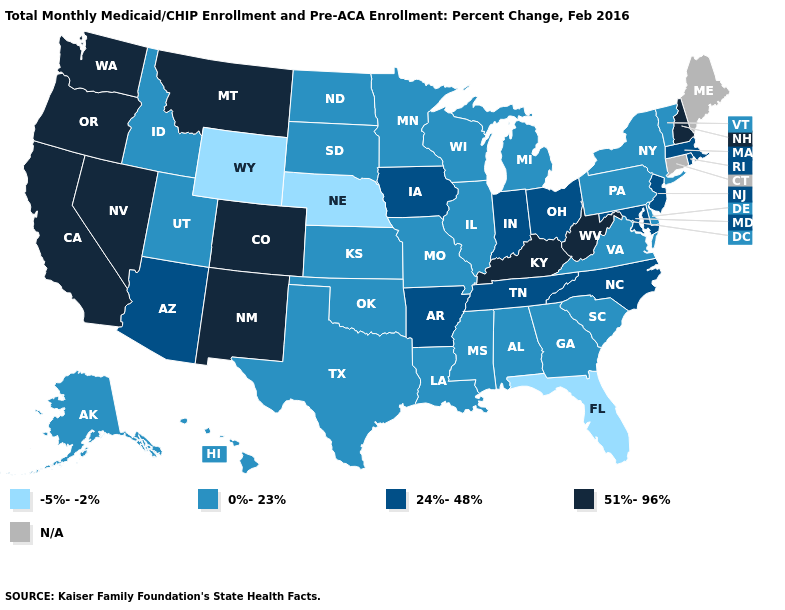Name the states that have a value in the range 51%-96%?
Write a very short answer. California, Colorado, Kentucky, Montana, Nevada, New Hampshire, New Mexico, Oregon, Washington, West Virginia. Name the states that have a value in the range N/A?
Be succinct. Connecticut, Maine. What is the value of Nevada?
Be succinct. 51%-96%. What is the highest value in states that border Oklahoma?
Quick response, please. 51%-96%. What is the value of Delaware?
Be succinct. 0%-23%. Name the states that have a value in the range 24%-48%?
Give a very brief answer. Arizona, Arkansas, Indiana, Iowa, Maryland, Massachusetts, New Jersey, North Carolina, Ohio, Rhode Island, Tennessee. Name the states that have a value in the range 24%-48%?
Keep it brief. Arizona, Arkansas, Indiana, Iowa, Maryland, Massachusetts, New Jersey, North Carolina, Ohio, Rhode Island, Tennessee. Name the states that have a value in the range 0%-23%?
Quick response, please. Alabama, Alaska, Delaware, Georgia, Hawaii, Idaho, Illinois, Kansas, Louisiana, Michigan, Minnesota, Mississippi, Missouri, New York, North Dakota, Oklahoma, Pennsylvania, South Carolina, South Dakota, Texas, Utah, Vermont, Virginia, Wisconsin. What is the highest value in the USA?
Write a very short answer. 51%-96%. What is the value of Idaho?
Concise answer only. 0%-23%. What is the value of Wisconsin?
Keep it brief. 0%-23%. Which states have the lowest value in the USA?
Give a very brief answer. Florida, Nebraska, Wyoming. Name the states that have a value in the range 24%-48%?
Keep it brief. Arizona, Arkansas, Indiana, Iowa, Maryland, Massachusetts, New Jersey, North Carolina, Ohio, Rhode Island, Tennessee. Name the states that have a value in the range 0%-23%?
Short answer required. Alabama, Alaska, Delaware, Georgia, Hawaii, Idaho, Illinois, Kansas, Louisiana, Michigan, Minnesota, Mississippi, Missouri, New York, North Dakota, Oklahoma, Pennsylvania, South Carolina, South Dakota, Texas, Utah, Vermont, Virginia, Wisconsin. 